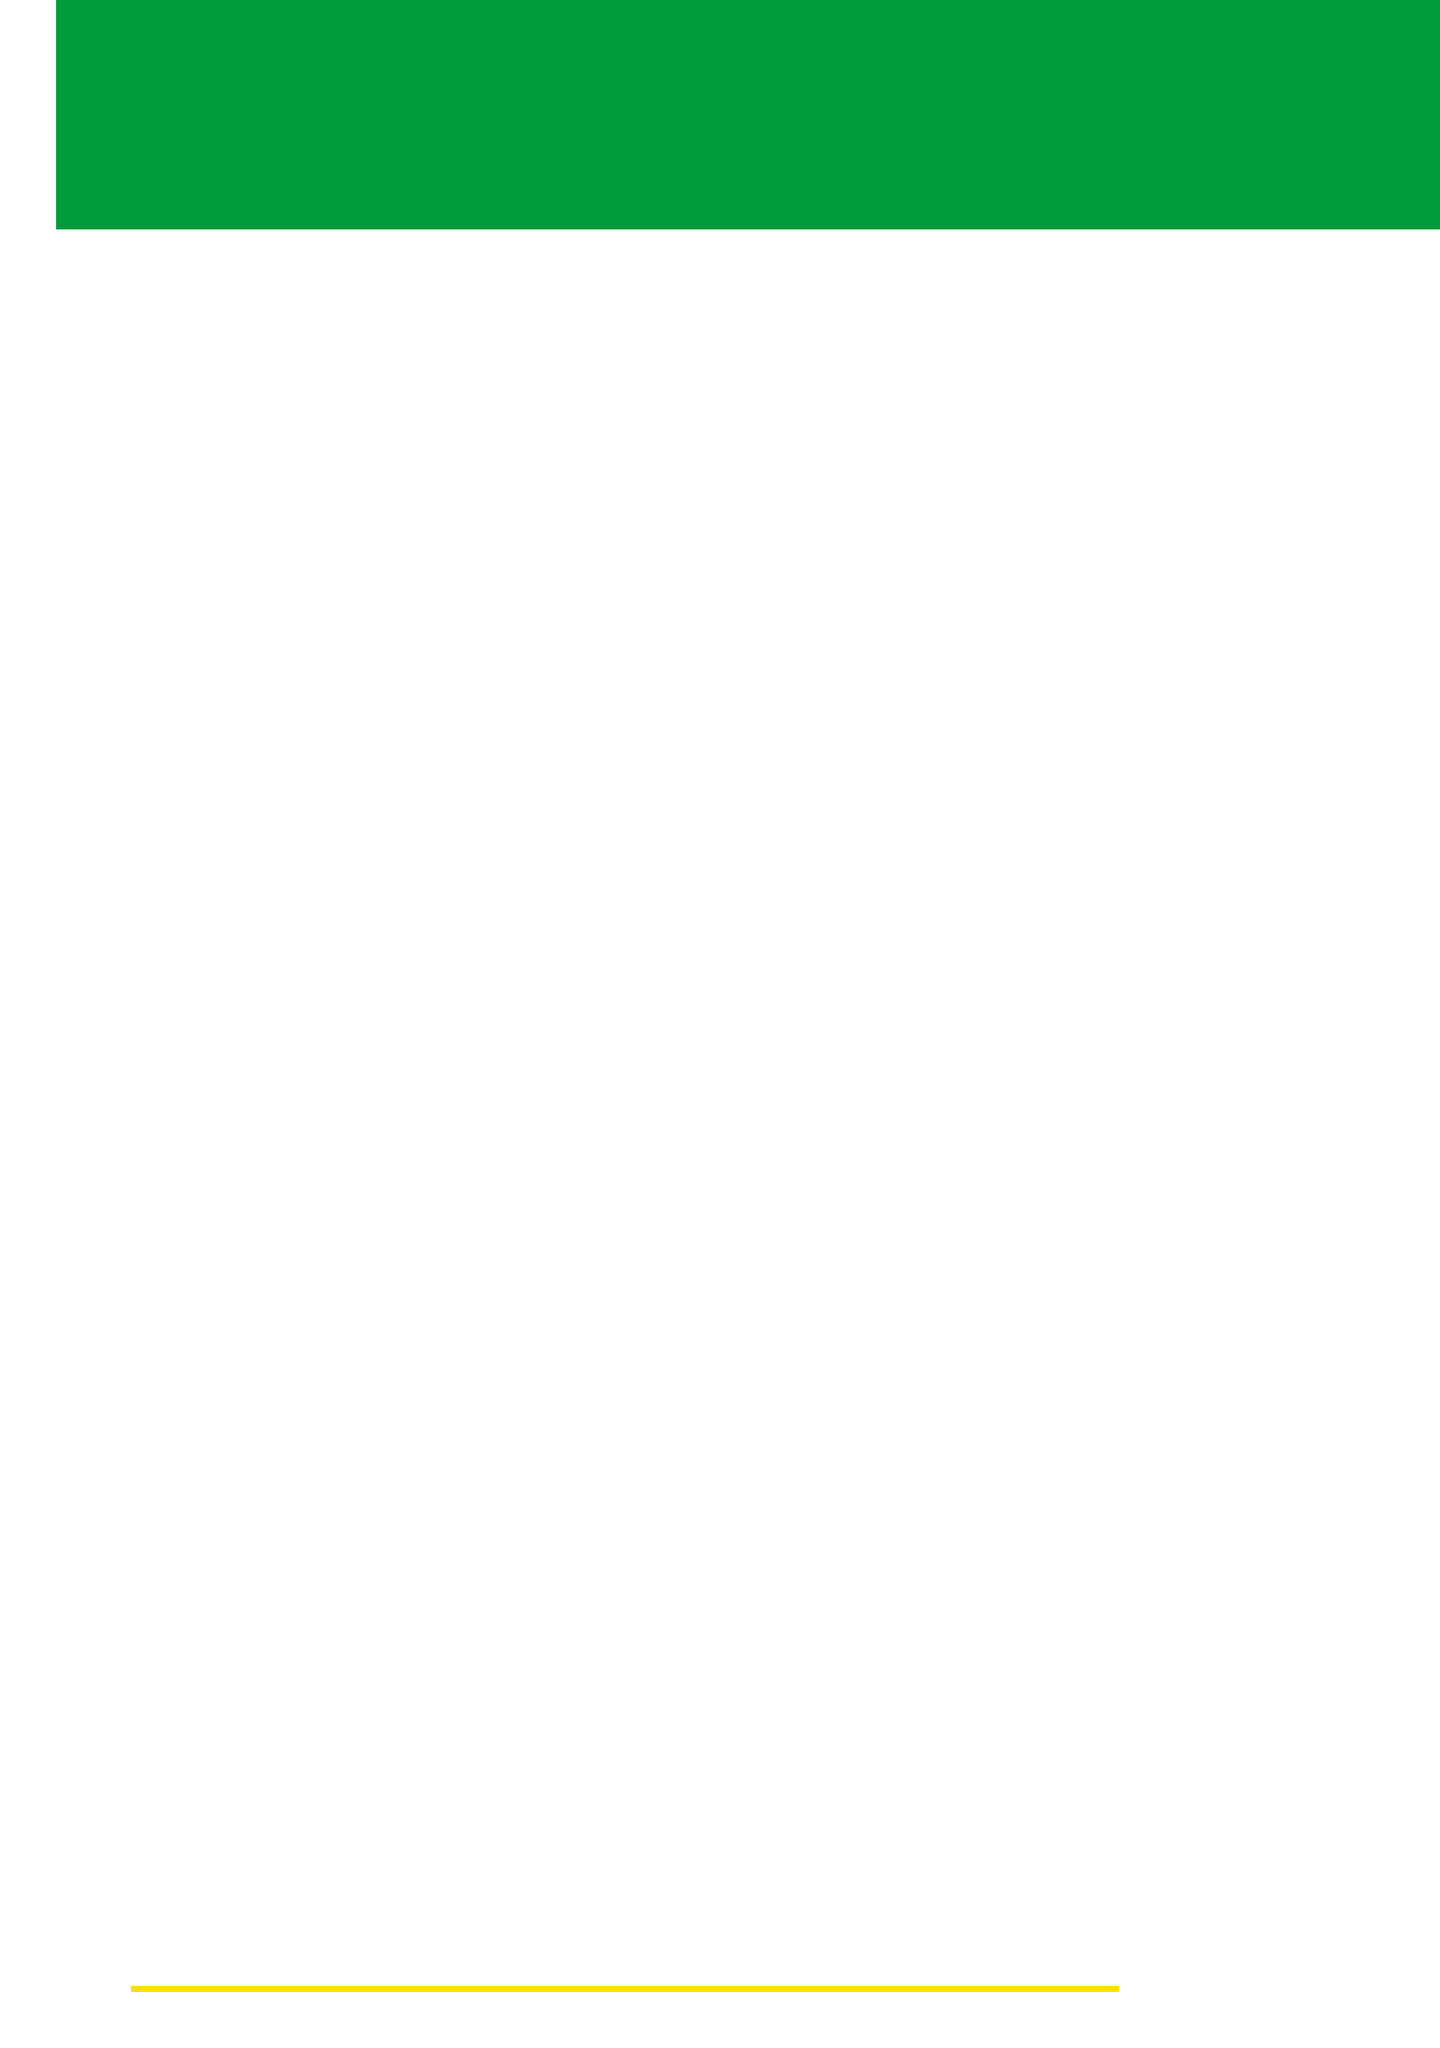What are the primary rackets listed? The primary rackets are specified as Yonex Astrox 88D Pro and Victor Jetspeed S 10.
Answer: Yonex Astrox 88D Pro, Victor Jetspeed S 10 Which accessory helps with hand sweat? The item that helps absorb sweat from hands is identified in the accessories section of the document.
Answer: Sweatbands What type of shuttlecocks are recommended for competition? The document specifies which shuttlecocks are competition grade under essential equipment.
Answer: Yonex Aerosensa 50 How many sets of national team uniforms should be packed? The document suggests packing multiple sets of national team uniforms, indicating more than one but not specifying a number.
Answer: Multiple sets What specialized device alerts deaf athletes of match notifications? The device specifically mentioned for match notifications for deaf athletes is in the specialized equipment section.
Answer: Vibrating watch Which clothing is recommended for hot climates? The document refers to certain clothing choices that are suggested for hot weather conditions or indoor environments.
Answer: Light-colored clothing What type of medications should be included in the travel essentials? The travel essentials highlight personal items necessary for health, specifically medications.
Answer: Personal medications What should athletes check for BWF regulations? The document strongly indicates an action related to checking compliance with specific badminton regulations.
Answer: Equipment regulations What type of charger is recommended for travel? The travel essentials include a specific type of charger that is essential for mobile devices while traveling.
Answer: Portable charger 